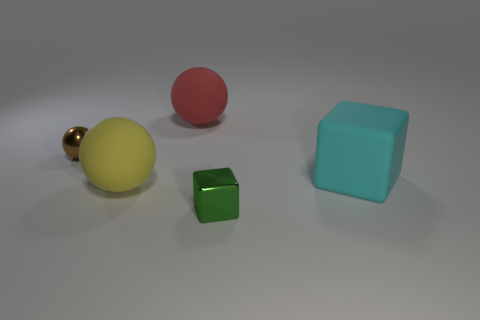Add 4 yellow metallic balls. How many objects exist? 9 Subtract all spheres. How many objects are left? 2 Subtract all tiny red cylinders. Subtract all big cyan rubber cubes. How many objects are left? 4 Add 4 small green blocks. How many small green blocks are left? 5 Add 5 purple shiny things. How many purple shiny things exist? 5 Subtract 0 purple blocks. How many objects are left? 5 